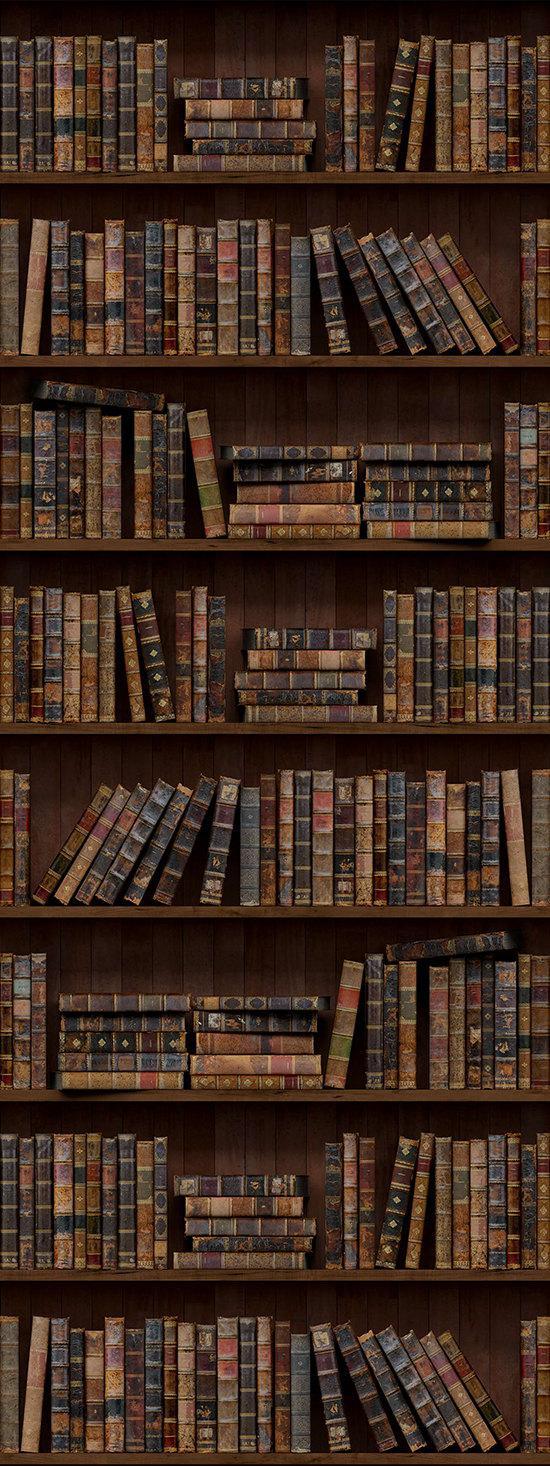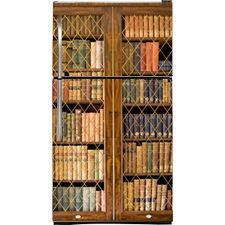The first image is the image on the left, the second image is the image on the right. Evaluate the accuracy of this statement regarding the images: "there is a room with a bookshelf made of dark wood and a leather sofa in front of it". Is it true? Answer yes or no. No. The first image is the image on the left, the second image is the image on the right. For the images displayed, is the sentence "In one image there are books on a bookshelf locked up behind glass." factually correct? Answer yes or no. Yes. 